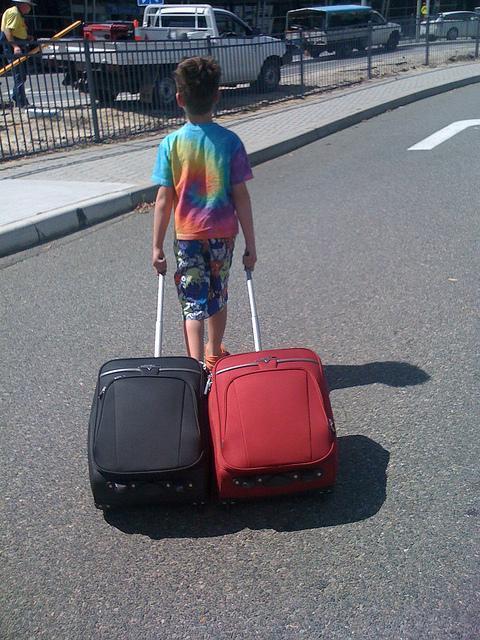How many trucks are there?
Give a very brief answer. 2. How many people are there?
Give a very brief answer. 2. How many suitcases can you see?
Give a very brief answer. 2. 